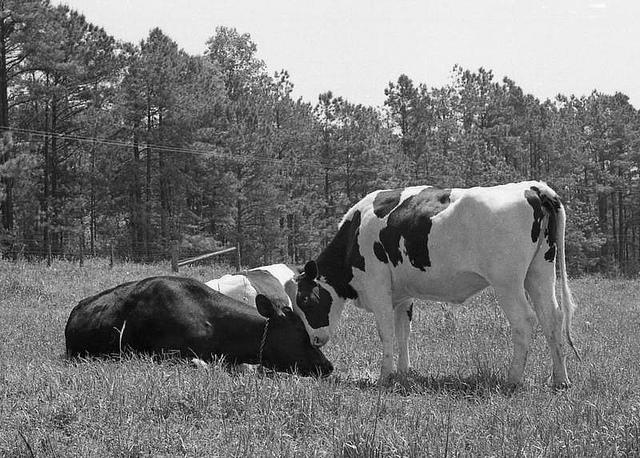Are these cows friends?
Be succinct. Yes. What color is the grass?
Concise answer only. Gray. Could this be in the wild?
Quick response, please. Yes. What are these animals?
Answer briefly. Cows. How many cows in the picture?
Write a very short answer. 3. 